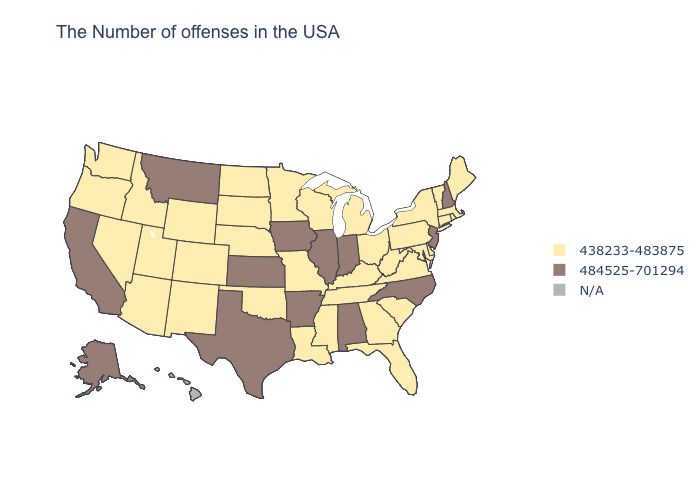Does Maine have the lowest value in the Northeast?
Give a very brief answer. Yes. Name the states that have a value in the range 484525-701294?
Answer briefly. New Hampshire, New Jersey, North Carolina, Indiana, Alabama, Illinois, Arkansas, Iowa, Kansas, Texas, Montana, California, Alaska. Does Mississippi have the lowest value in the USA?
Keep it brief. Yes. Is the legend a continuous bar?
Short answer required. No. Among the states that border Colorado , which have the lowest value?
Give a very brief answer. Nebraska, Oklahoma, Wyoming, New Mexico, Utah, Arizona. What is the lowest value in states that border New York?
Write a very short answer. 438233-483875. What is the lowest value in states that border Montana?
Answer briefly. 438233-483875. Which states hav the highest value in the MidWest?
Concise answer only. Indiana, Illinois, Iowa, Kansas. Does Georgia have the highest value in the South?
Keep it brief. No. Which states have the lowest value in the West?
Keep it brief. Wyoming, Colorado, New Mexico, Utah, Arizona, Idaho, Nevada, Washington, Oregon. What is the lowest value in states that border Kansas?
Give a very brief answer. 438233-483875. What is the value of Massachusetts?
Concise answer only. 438233-483875. Does Tennessee have the lowest value in the USA?
Concise answer only. Yes. What is the lowest value in the USA?
Be succinct. 438233-483875. 